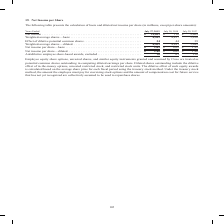According to Cisco Systems's financial document, What does diluted shares outstanding include? the dilutive effect of in-the-money options, unvested restricted stock, and restricted stock units.. The document states: "ings per share. Diluted shares outstanding include the dilutive effect of in-the-money options, unvested restricted stock, and restricted stock units...." Also, What was the basic weighted-average shares in 2019? According to the financial document, 4,419 (in millions). The relevant text states: "621 $ 110 $ 9,609 Weighted-average shares—basic . 4,419 4,837 5,010 Effect of dilutive potential common shares . 34 44 39 Weighted-average shares—diluted ...." Also, What was the basic net income per share in 2018? According to the financial document, 0.02. The relevant text states: "4,881 5,049 Net income per share—basic . $ 2.63 $ 0.02 $ 1.92 Net income per share—diluted. . $ 2.61 $ 0.02 $ 1.90 Antidilutive employee share-based award..." Also, can you calculate: What was the change in the Effect of dilutive potential common shares between 2017 and 2018? Based on the calculation: 44-39, the result is 5 (in millions). This is based on the information: "ffect of dilutive potential common shares . 34 44 39 Weighted-average shares—diluted . 4,453 4,881 5,049 Net income per share—basic . $ 2.63 $ 0.02 $ 1. 0 Effect of dilutive potential common shares . ..." The key data points involved are: 39, 44. Also, How many years did the basic weighted-average shares exceed $5,000 million? Based on the analysis, there are 1 instances. The counting process: 2017. Also, can you calculate: What was the percentage change in net income between 2018 and 2019? To answer this question, I need to perform calculations using the financial data. The calculation is: (11,621-110)/110, which equals 10464.55 (percentage). This is based on the information: "ly 28, 2018 July 29, 2017 Net income . $ 11,621 $ 110 $ 9,609 Weighted-average shares—basic . 4,419 4,837 5,010 Effect of dilutive potential common share , 2019 July 28, 2018 July 29, 2017 Net income ..." The key data points involved are: 11,621, 110. 